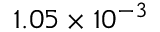<formula> <loc_0><loc_0><loc_500><loc_500>1 . 0 5 \times 1 0 ^ { - 3 }</formula> 